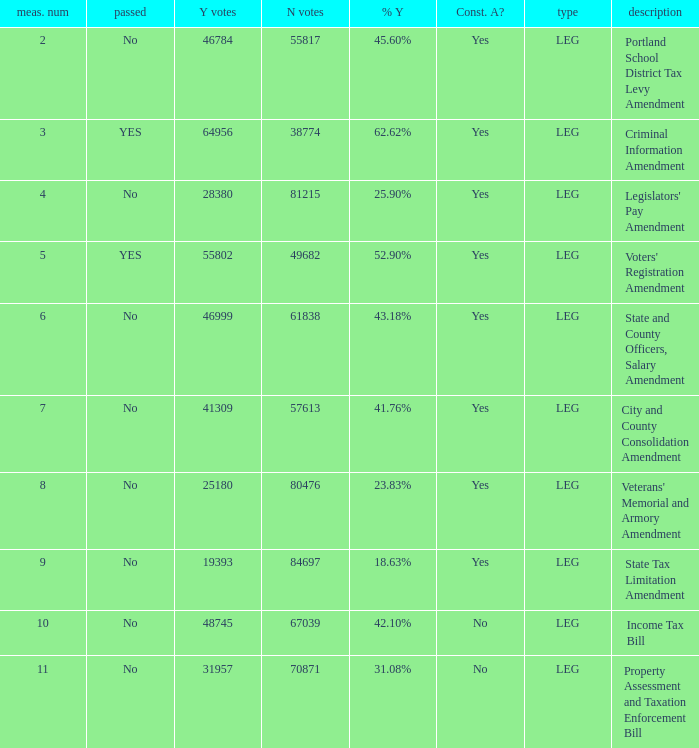Give me the full table as a dictionary. {'header': ['meas. num', 'passed', 'Y votes', 'N votes', '% Y', 'Const. A?', 'type', 'description'], 'rows': [['2', 'No', '46784', '55817', '45.60%', 'Yes', 'LEG', 'Portland School District Tax Levy Amendment'], ['3', 'YES', '64956', '38774', '62.62%', 'Yes', 'LEG', 'Criminal Information Amendment'], ['4', 'No', '28380', '81215', '25.90%', 'Yes', 'LEG', "Legislators' Pay Amendment"], ['5', 'YES', '55802', '49682', '52.90%', 'Yes', 'LEG', "Voters' Registration Amendment"], ['6', 'No', '46999', '61838', '43.18%', 'Yes', 'LEG', 'State and County Officers, Salary Amendment'], ['7', 'No', '41309', '57613', '41.76%', 'Yes', 'LEG', 'City and County Consolidation Amendment'], ['8', 'No', '25180', '80476', '23.83%', 'Yes', 'LEG', "Veterans' Memorial and Armory Amendment"], ['9', 'No', '19393', '84697', '18.63%', 'Yes', 'LEG', 'State Tax Limitation Amendment'], ['10', 'No', '48745', '67039', '42.10%', 'No', 'LEG', 'Income Tax Bill'], ['11', 'No', '31957', '70871', '31.08%', 'No', 'LEG', 'Property Assessment and Taxation Enforcement Bill']]} HOw many no votes were there when there were 45.60% yes votes 55817.0. 